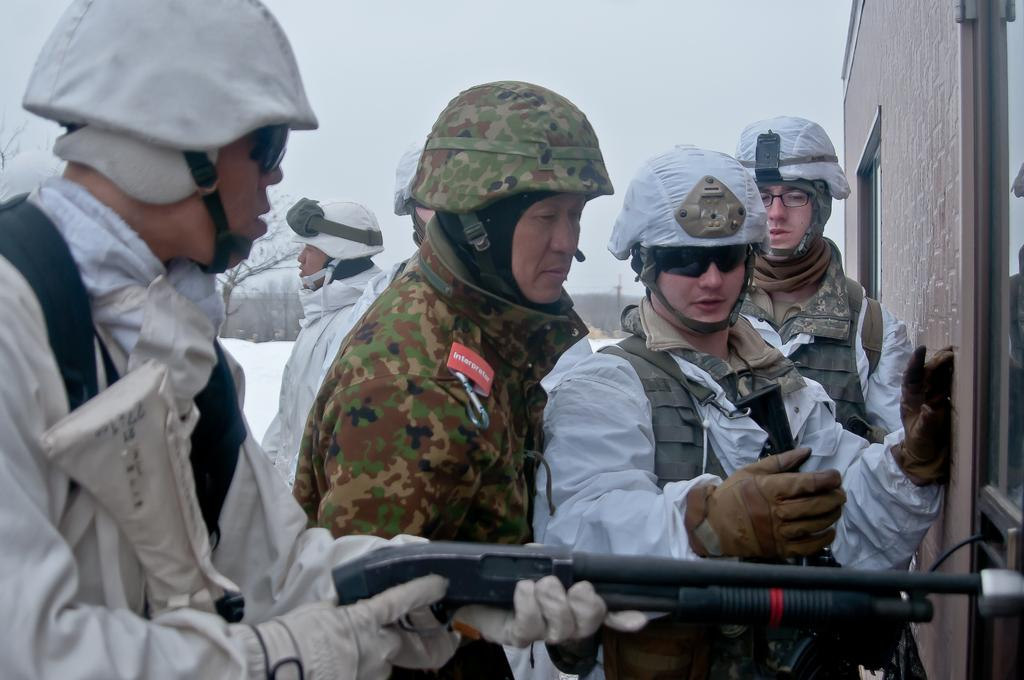What are the persons in the image wearing on their heads? The persons in the image are wearing helmets. What is the position of the persons in the image? The persons are standing. What can be seen in the right corner of the image? There is a building in the right corner of the image. What type of natural scenery is visible in the background of the image? There are trees in the background of the image. What type of seed is being planted by the persons in the image? There is no indication of planting or seeds in the image; the persons are wearing helmets and standing. What government policy is being discussed by the persons in the image? There is no indication of a discussion or government policy in the image; the persons are wearing helmets and standing. 